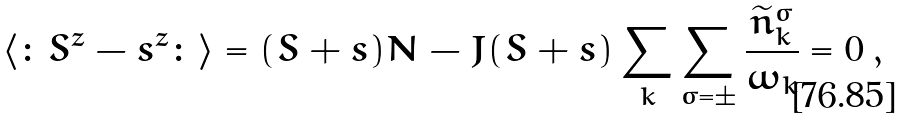Convert formula to latex. <formula><loc_0><loc_0><loc_500><loc_500>\langle \colon S ^ { z } - s ^ { z } \colon \rangle = ( S + s ) N - J ( S + s ) \sum _ { k } \sum _ { \sigma = \pm } \frac { \widetilde { n } ^ { \sigma } _ { k } } { \omega _ { k } } = 0 \, ,</formula> 